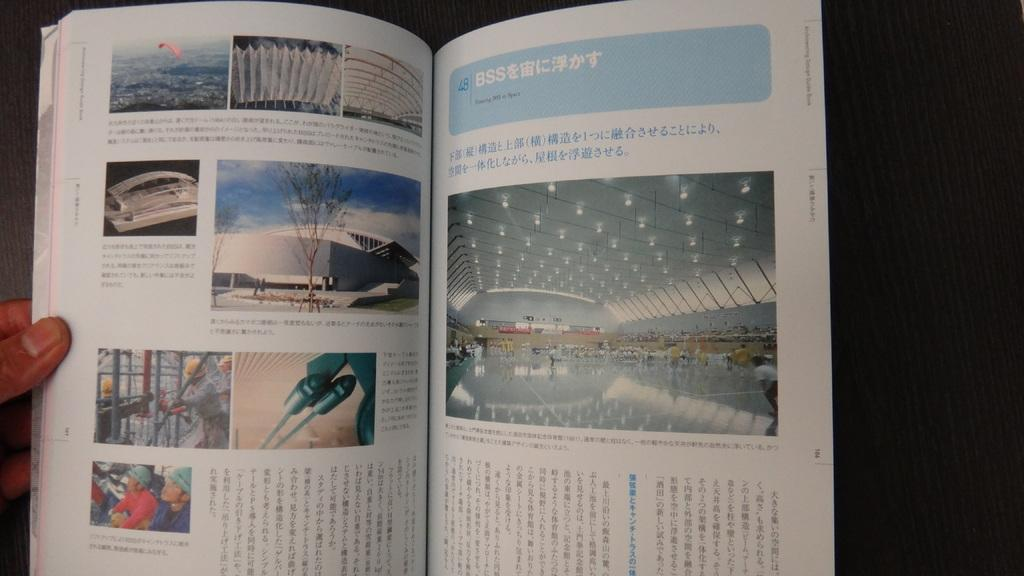<image>
Provide a brief description of the given image. a book that has the letters BSS on it 